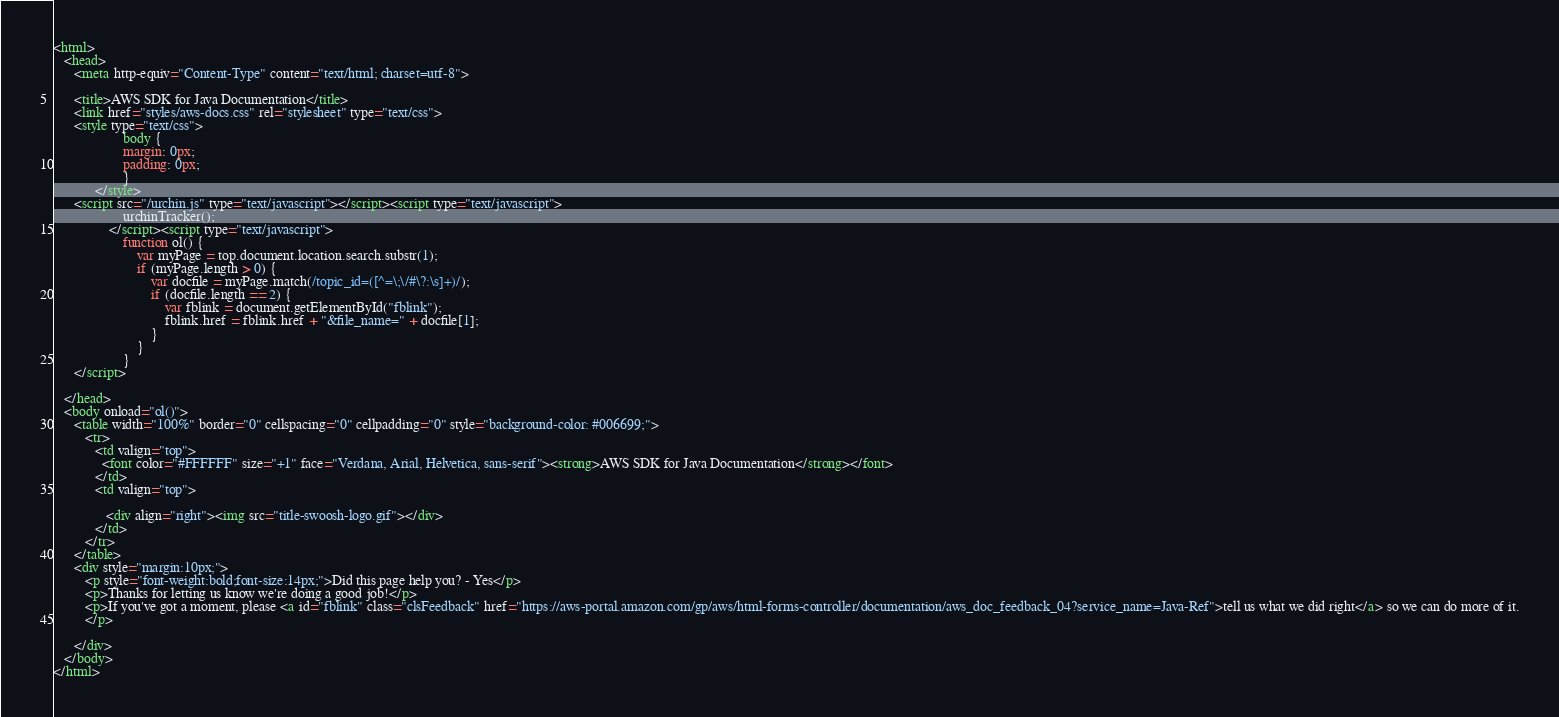<code> <loc_0><loc_0><loc_500><loc_500><_HTML_><html>
   <head>
      <meta http-equiv="Content-Type" content="text/html; charset=utf-8">

      <title>AWS SDK for Java Documentation</title>
      <link href="styles/aws-docs.css" rel="stylesheet" type="text/css">
      <style type="text/css">
                    body {
                    margin: 0px;
                    padding: 0px;
                    }
			</style>
      <script src="/urchin.js" type="text/javascript"></script><script type="text/javascript">
					urchinTracker();
				</script><script type="text/javascript">
					function ol() {
						var myPage = top.document.location.search.substr(1);
						if (myPage.length > 0) {
							var docfile = myPage.match(/topic_id=([^=\;\/#\?:\s]+)/);
							if (docfile.length == 2) {
								var fblink = document.getElementById("fblink");
								fblink.href = fblink.href + "&file_name=" + docfile[1];
							}
						}
					}
      </script>

   </head>
   <body onload="ol()">
      <table width="100%" border="0" cellspacing="0" cellpadding="0" style="background-color: #006699;">
         <tr>
            <td valign="top">
              <font color="#FFFFFF" size="+1" face="Verdana, Arial, Helvetica, sans-serif"><strong>AWS SDK for Java Documentation</strong></font>
            </td>
            <td valign="top">

               <div align="right"><img src="title-swoosh-logo.gif"></div>
            </td>
         </tr>
      </table>
      <div style="margin:10px;">
         <p style="font-weight:bold;font-size:14px;">Did this page help you? - Yes</p>
         <p>Thanks for letting us know we're doing a good job!</p>
         <p>If you've got a moment, please <a id="fblink" class="clsFeedback" href="https://aws-portal.amazon.com/gp/aws/html-forms-controller/documentation/aws_doc_feedback_04?service_name=Java-Ref">tell us what we did right</a> so we can do more of it.
         </p>

      </div>
   </body>
</html></code> 